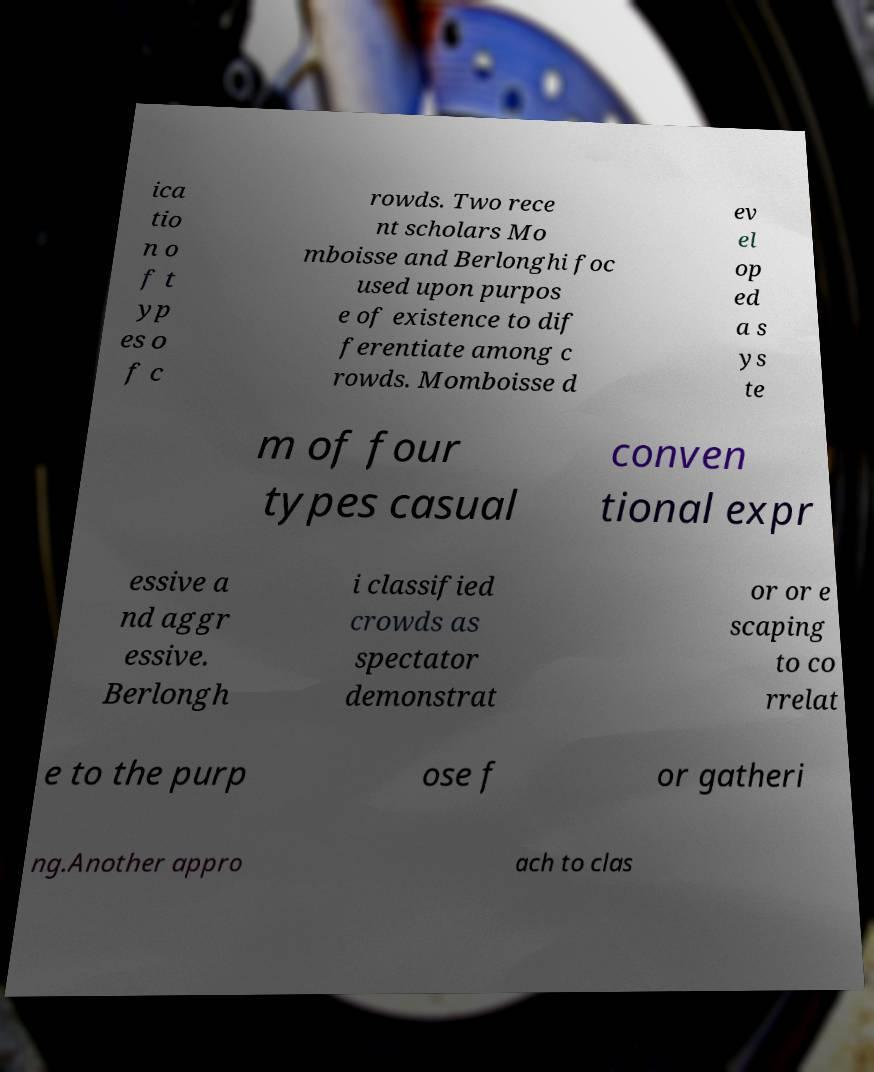For documentation purposes, I need the text within this image transcribed. Could you provide that? ica tio n o f t yp es o f c rowds. Two rece nt scholars Mo mboisse and Berlonghi foc used upon purpos e of existence to dif ferentiate among c rowds. Momboisse d ev el op ed a s ys te m of four types casual conven tional expr essive a nd aggr essive. Berlongh i classified crowds as spectator demonstrat or or e scaping to co rrelat e to the purp ose f or gatheri ng.Another appro ach to clas 